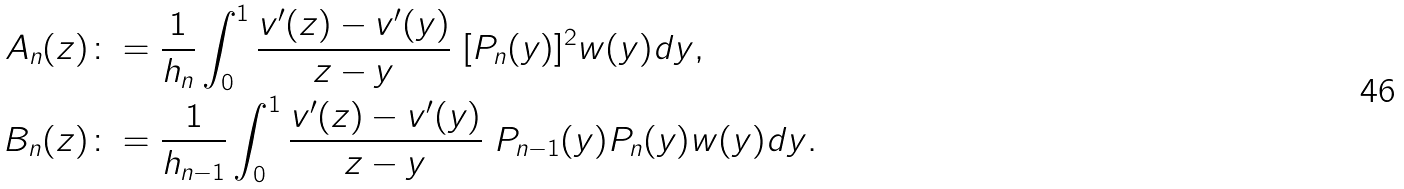<formula> <loc_0><loc_0><loc_500><loc_500>A _ { n } ( z ) & \colon = \frac { 1 } { h _ { n } } \int _ { 0 } ^ { 1 } \frac { v ^ { \prime } ( z ) - v ^ { \prime } ( y ) } { z - y } \ [ P _ { n } ( y ) ] ^ { 2 } w ( y ) d y , \\ B _ { n } ( z ) & \colon = \frac { 1 } { h _ { n - 1 } } \int _ { 0 } ^ { 1 } \frac { v ^ { \prime } ( z ) - v ^ { \prime } ( y ) } { z - y } \ P _ { n - 1 } ( y ) P _ { n } ( y ) w ( y ) d y .</formula> 